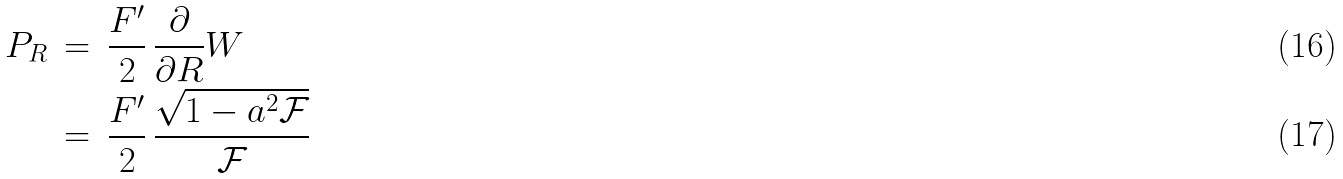<formula> <loc_0><loc_0><loc_500><loc_500>P _ { R } \, & = \, \frac { F ^ { \prime } } { 2 } \, \frac { \partial } { \partial R } W \\ & = \, \frac { F ^ { \prime } } { 2 } \, \frac { \sqrt { 1 - a ^ { 2 } \mathcal { F } } } { \mathcal { F } }</formula> 